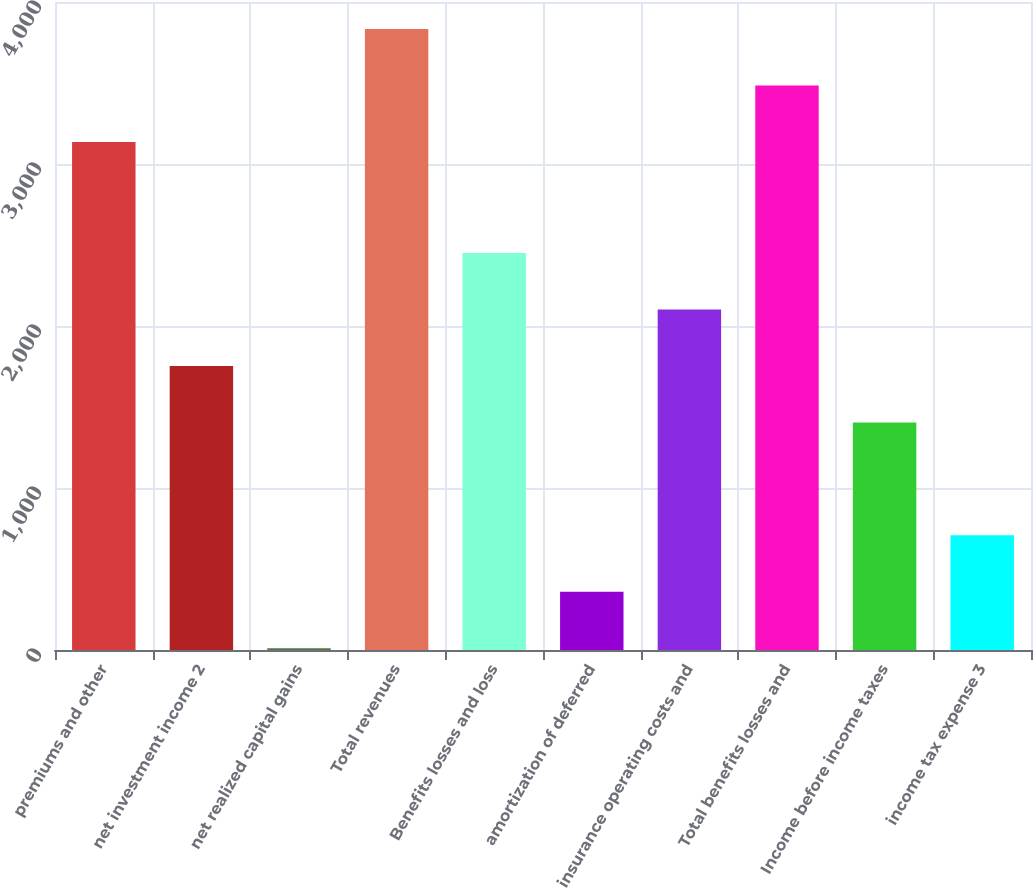<chart> <loc_0><loc_0><loc_500><loc_500><bar_chart><fcel>premiums and other<fcel>net investment income 2<fcel>net realized capital gains<fcel>Total revenues<fcel>Benefits losses and loss<fcel>amortization of deferred<fcel>insurance operating costs and<fcel>Total benefits losses and<fcel>Income before income taxes<fcel>income tax expense 3<nl><fcel>3136<fcel>1753.5<fcel>11<fcel>3833<fcel>2450.5<fcel>359.5<fcel>2102<fcel>3484.5<fcel>1405<fcel>708<nl></chart> 